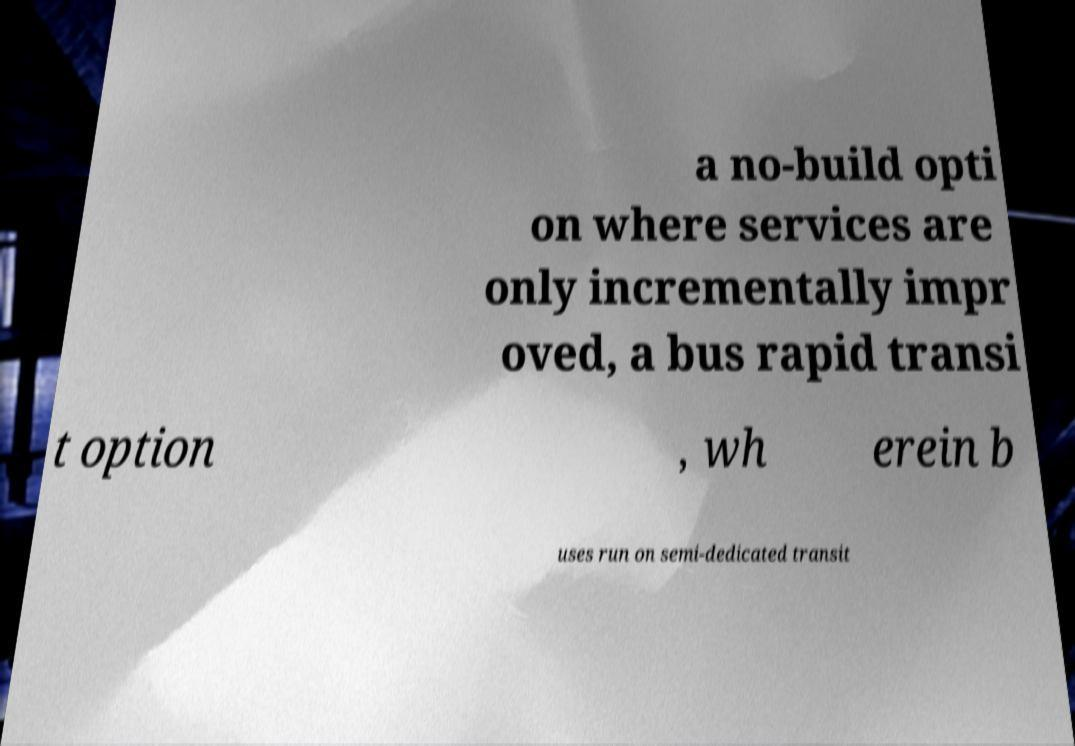Can you accurately transcribe the text from the provided image for me? a no-build opti on where services are only incrementally impr oved, a bus rapid transi t option , wh erein b uses run on semi-dedicated transit 